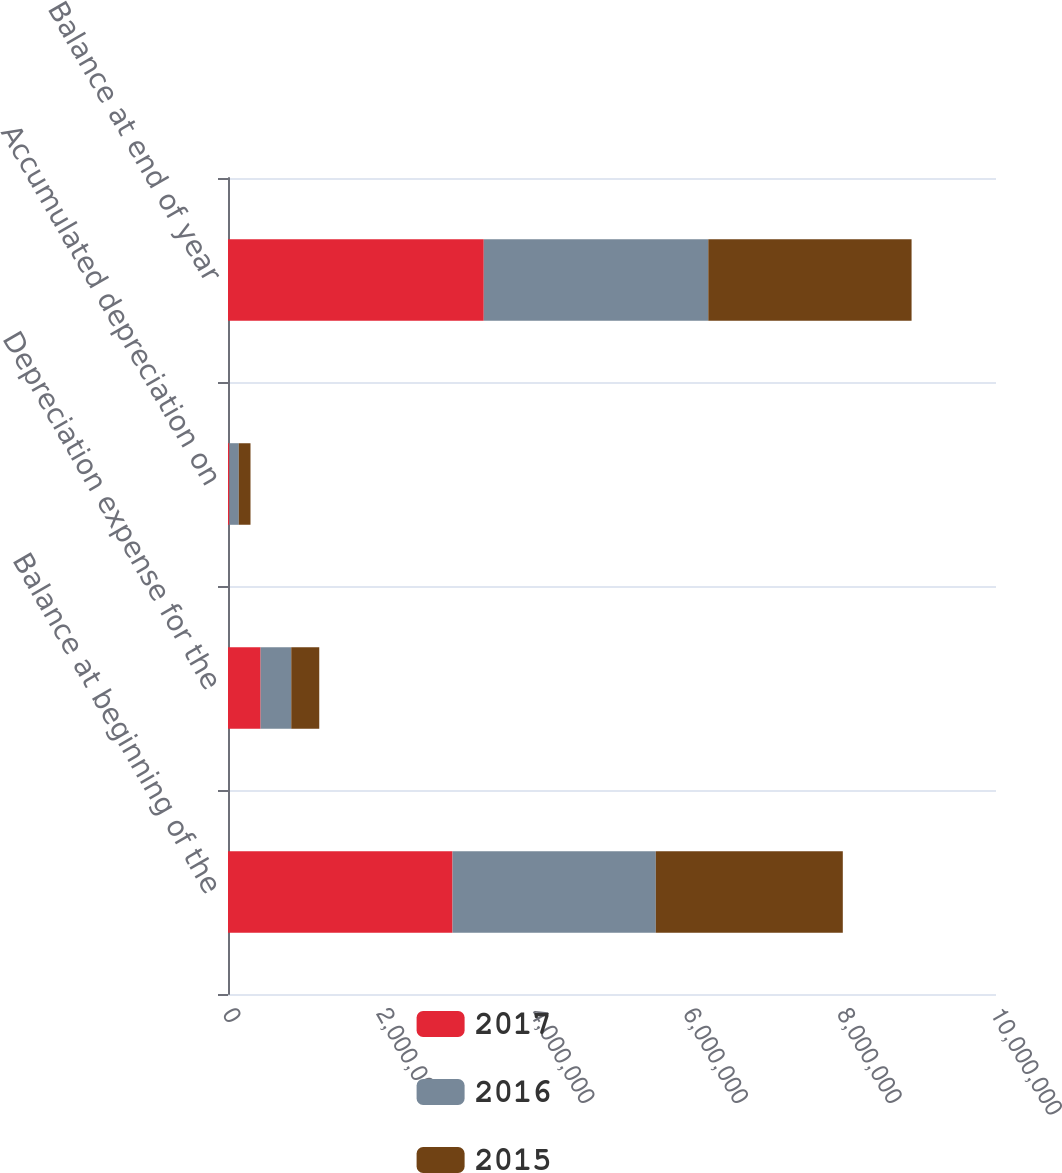Convert chart. <chart><loc_0><loc_0><loc_500><loc_500><stacked_bar_chart><ecel><fcel>Balance at beginning of the<fcel>Depreciation expense for the<fcel>Accumulated depreciation on<fcel>Balance at end of year<nl><fcel>2017<fcel>2.92362e+06<fcel>424772<fcel>18231<fcel>3.33017e+06<nl><fcel>2016<fcel>2.64687e+06<fcel>398904<fcel>122153<fcel>2.92362e+06<nl><fcel>2015<fcel>2.43477e+06<fcel>364622<fcel>152520<fcel>2.64687e+06<nl></chart> 